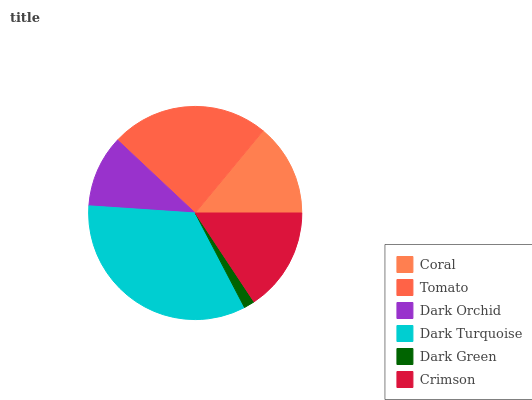Is Dark Green the minimum?
Answer yes or no. Yes. Is Dark Turquoise the maximum?
Answer yes or no. Yes. Is Tomato the minimum?
Answer yes or no. No. Is Tomato the maximum?
Answer yes or no. No. Is Tomato greater than Coral?
Answer yes or no. Yes. Is Coral less than Tomato?
Answer yes or no. Yes. Is Coral greater than Tomato?
Answer yes or no. No. Is Tomato less than Coral?
Answer yes or no. No. Is Crimson the high median?
Answer yes or no. Yes. Is Coral the low median?
Answer yes or no. Yes. Is Dark Orchid the high median?
Answer yes or no. No. Is Dark Orchid the low median?
Answer yes or no. No. 